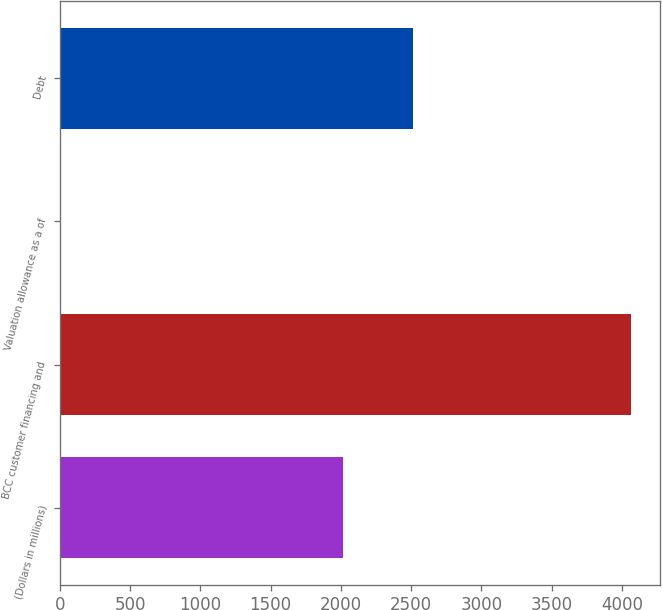<chart> <loc_0><loc_0><loc_500><loc_500><bar_chart><fcel>(Dollars in millions)<fcel>BCC customer financing and<fcel>Valuation allowance as a of<fcel>Debt<nl><fcel>2012<fcel>4066<fcel>2<fcel>2511<nl></chart> 